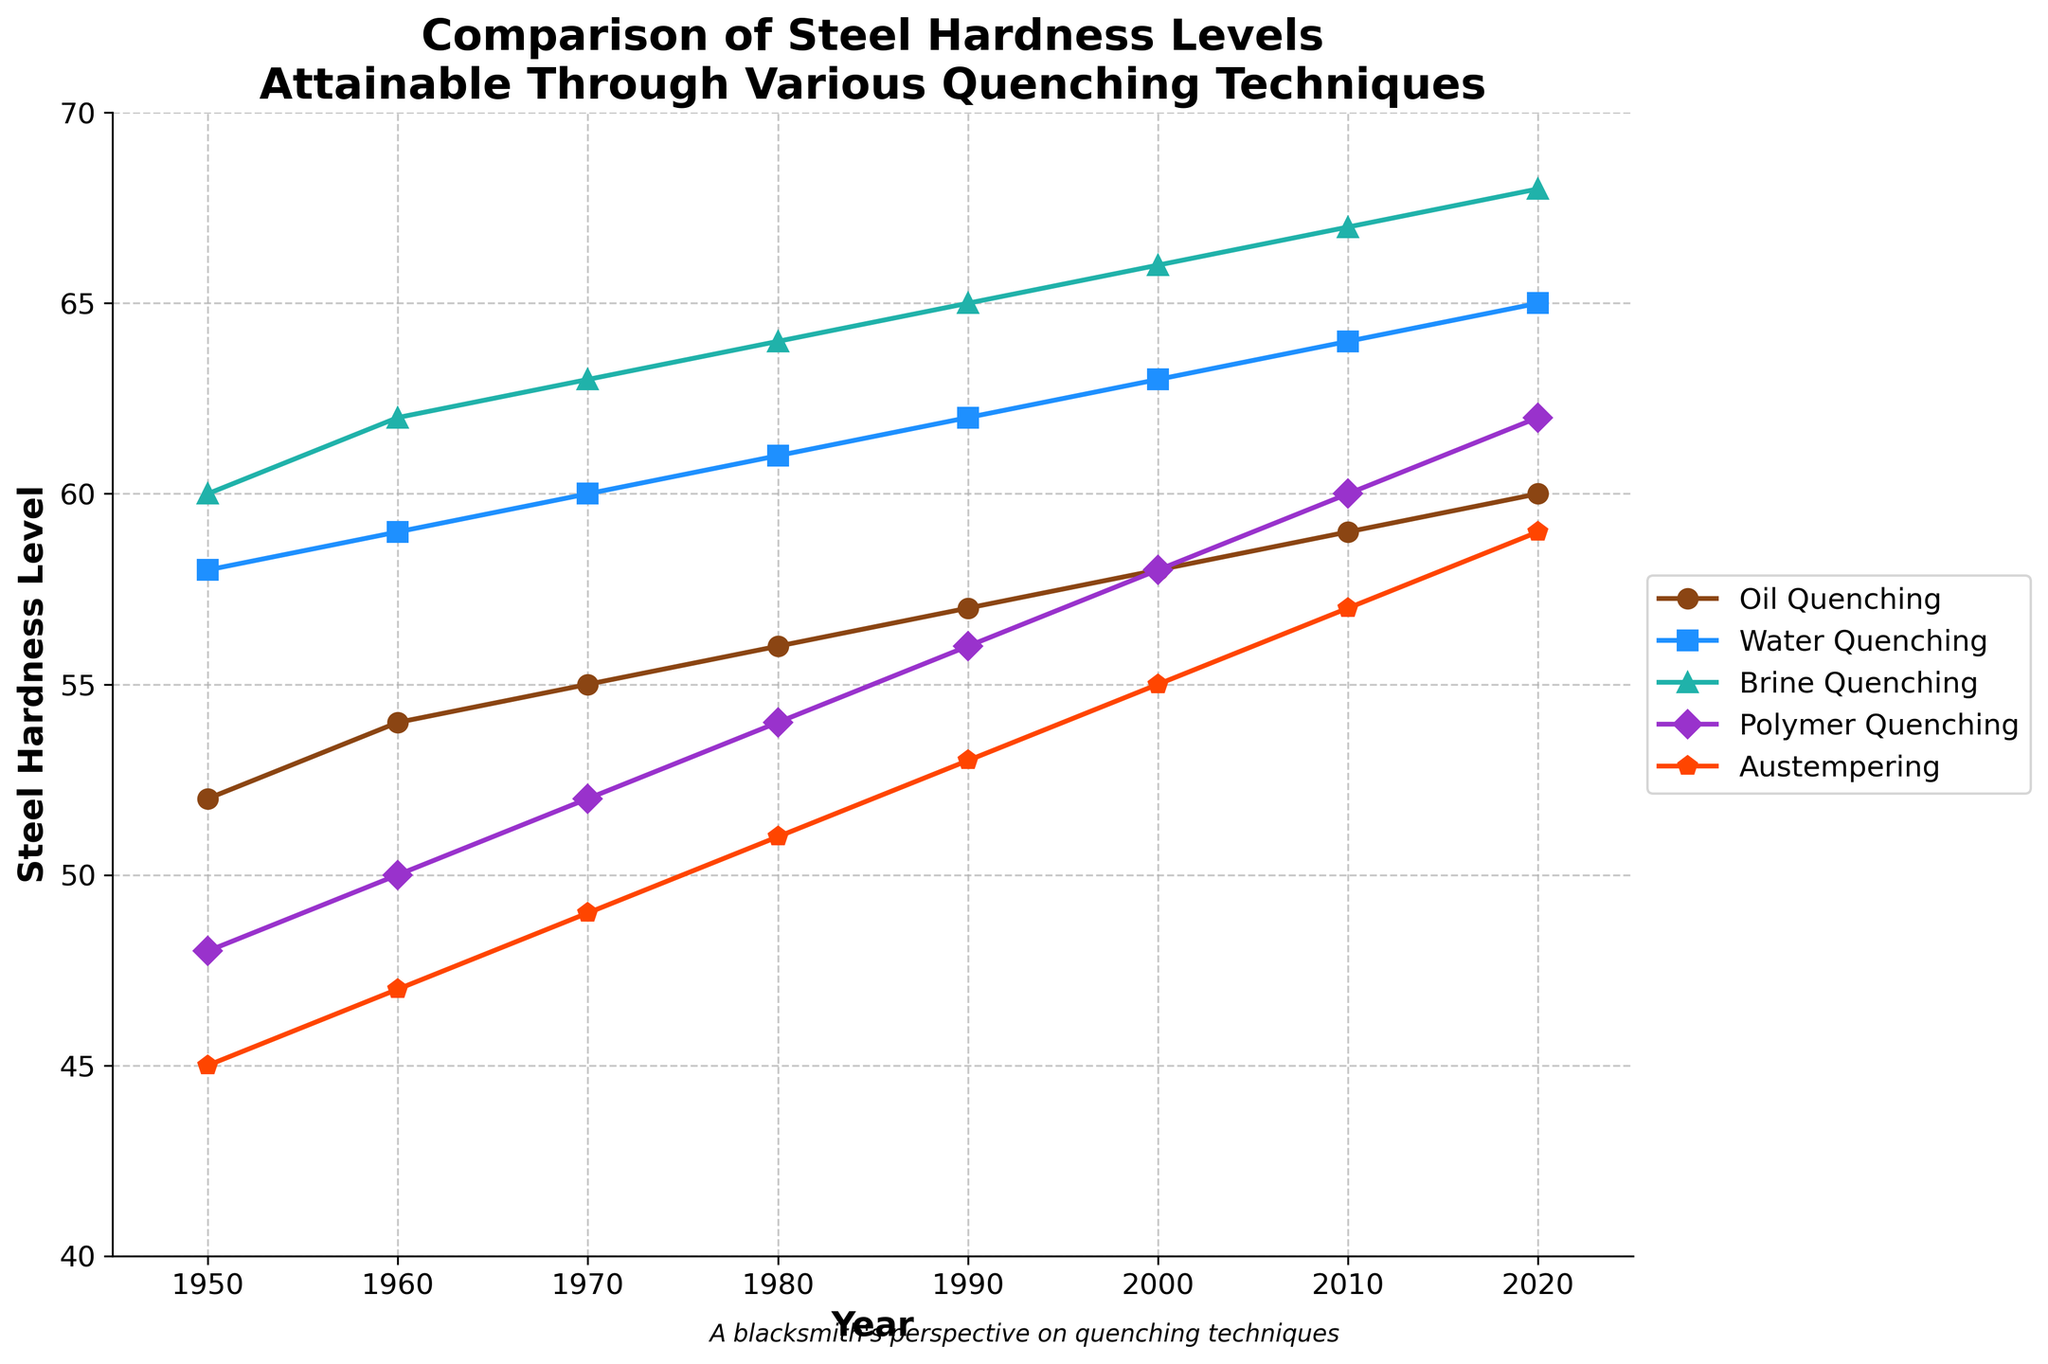Which quenching technique showed the highest increase in steel hardness levels from 1950 to 2020? To determine which technique had the highest increase in hardness, subtract the 1950 value from the 2020 value for each technique. The differences are: Oil Quenching (60-52=8), Water Quenching (65-58=7), Brine Quenching (68-60=8), Polymer Quenching (62-48=14), Austempering (59-45=14). The highest increase is tied between Polymer Quenching and Austempering, each with an increase of 14.
Answer: Polymer Quenching and Austempering In which year did Oil Quenching and Polymer Quenching have the same hardness level? Look for the point where the Oil Quenching and Polymer Quenching lines intersect. This occurs when both lines have the same y-value. The only year this happens in the data is 2020, where both techniques have a hardness level of 60.
Answer: 2020 Which quenching technique consistently provided the highest hardness level over the years? Compare the highest values of each line across all years. Brine Quenching has the highest values consistently (60 in 1950 to 68 in 2020).
Answer: Brine Quenching What is the difference in steel hardness between Water Quenching and Austempering in 1990? Subtract the Austempering hardness value from the Water Quenching hardness value in 1990, i.e., 62 - 53.
Answer: 9 Which quenching technique showed the least increase in hardness from 1950 to 2020? To find the least increase, calculate the difference between the 2020 and 1950 values for each technique. The differences are: Oil Quenching (8), Water Quenching (7), Brine Quenching (8), Polymer Quenching (14), Austempering (14). Water Quenching has the smallest increase of 7.
Answer: Water Quenching How does the trend of hardness values for Austempering compare to that of Oil Quenching? Both techniques show an increasing trend over the years. However, the Austempering technique starts lower than Oil Quenching in 1950 and ends up just one unit below in 2020.
Answer: Austempering increases slower than Oil Quenching but catches up significantly Which quenching technique had the sharpest increase in hardness levels between any two consecutive decades? Calculate the increase for every consecutive decade for each technique. Largest increase appears between 1950 and 1960 for Brine Quenching (62 - 60 = 2).
Answer: Brine Quenching (1950-1960) What is the average hardness level of Brine Quenching from 1980 to 2000? Calculate the average of Brine Quenching values for the years 1980, 1990, and 2000: (64 + 65 + 66) / 3.
Answer: 65 Does any two quenching techniques have equal hardness values in the year 2000? Check the hardness values listed for the year 2000 for all techniques. No two techniques have the same hardness level in this year.
Answer: No Which trend line is represented by a green color and what does it indicate about steel hardness? Identify the green color among the lines; it represents Polymer Quenching. The trend shows a steady increase in hardness from 48 in 1950 to 62 in 2020.
Answer: Polymer Quenching 